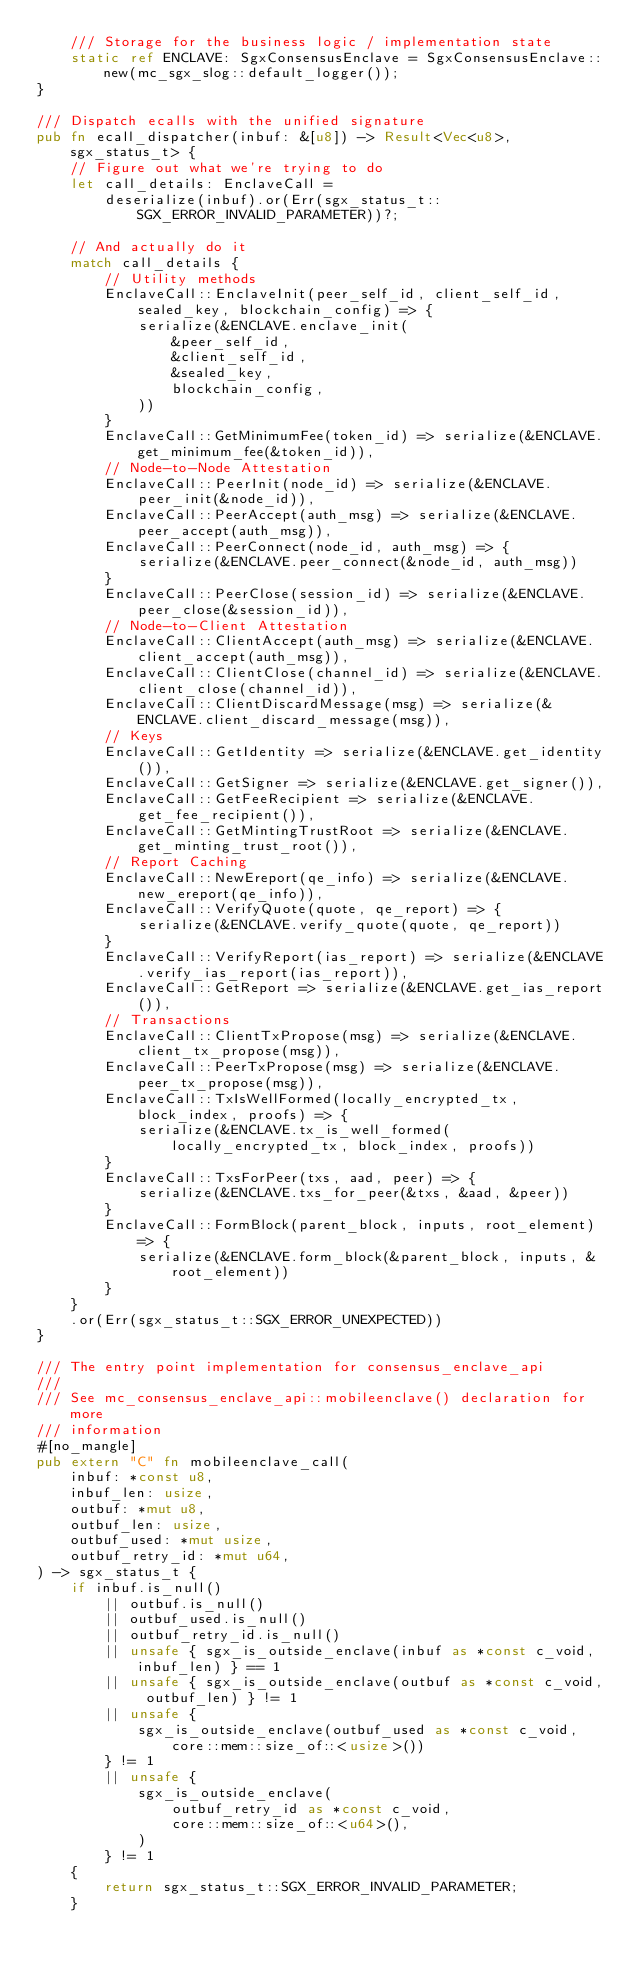Convert code to text. <code><loc_0><loc_0><loc_500><loc_500><_Rust_>    /// Storage for the business logic / implementation state
    static ref ENCLAVE: SgxConsensusEnclave = SgxConsensusEnclave::new(mc_sgx_slog::default_logger());
}

/// Dispatch ecalls with the unified signature
pub fn ecall_dispatcher(inbuf: &[u8]) -> Result<Vec<u8>, sgx_status_t> {
    // Figure out what we're trying to do
    let call_details: EnclaveCall =
        deserialize(inbuf).or(Err(sgx_status_t::SGX_ERROR_INVALID_PARAMETER))?;

    // And actually do it
    match call_details {
        // Utility methods
        EnclaveCall::EnclaveInit(peer_self_id, client_self_id, sealed_key, blockchain_config) => {
            serialize(&ENCLAVE.enclave_init(
                &peer_self_id,
                &client_self_id,
                &sealed_key,
                blockchain_config,
            ))
        }
        EnclaveCall::GetMinimumFee(token_id) => serialize(&ENCLAVE.get_minimum_fee(&token_id)),
        // Node-to-Node Attestation
        EnclaveCall::PeerInit(node_id) => serialize(&ENCLAVE.peer_init(&node_id)),
        EnclaveCall::PeerAccept(auth_msg) => serialize(&ENCLAVE.peer_accept(auth_msg)),
        EnclaveCall::PeerConnect(node_id, auth_msg) => {
            serialize(&ENCLAVE.peer_connect(&node_id, auth_msg))
        }
        EnclaveCall::PeerClose(session_id) => serialize(&ENCLAVE.peer_close(&session_id)),
        // Node-to-Client Attestation
        EnclaveCall::ClientAccept(auth_msg) => serialize(&ENCLAVE.client_accept(auth_msg)),
        EnclaveCall::ClientClose(channel_id) => serialize(&ENCLAVE.client_close(channel_id)),
        EnclaveCall::ClientDiscardMessage(msg) => serialize(&ENCLAVE.client_discard_message(msg)),
        // Keys
        EnclaveCall::GetIdentity => serialize(&ENCLAVE.get_identity()),
        EnclaveCall::GetSigner => serialize(&ENCLAVE.get_signer()),
        EnclaveCall::GetFeeRecipient => serialize(&ENCLAVE.get_fee_recipient()),
        EnclaveCall::GetMintingTrustRoot => serialize(&ENCLAVE.get_minting_trust_root()),
        // Report Caching
        EnclaveCall::NewEreport(qe_info) => serialize(&ENCLAVE.new_ereport(qe_info)),
        EnclaveCall::VerifyQuote(quote, qe_report) => {
            serialize(&ENCLAVE.verify_quote(quote, qe_report))
        }
        EnclaveCall::VerifyReport(ias_report) => serialize(&ENCLAVE.verify_ias_report(ias_report)),
        EnclaveCall::GetReport => serialize(&ENCLAVE.get_ias_report()),
        // Transactions
        EnclaveCall::ClientTxPropose(msg) => serialize(&ENCLAVE.client_tx_propose(msg)),
        EnclaveCall::PeerTxPropose(msg) => serialize(&ENCLAVE.peer_tx_propose(msg)),
        EnclaveCall::TxIsWellFormed(locally_encrypted_tx, block_index, proofs) => {
            serialize(&ENCLAVE.tx_is_well_formed(locally_encrypted_tx, block_index, proofs))
        }
        EnclaveCall::TxsForPeer(txs, aad, peer) => {
            serialize(&ENCLAVE.txs_for_peer(&txs, &aad, &peer))
        }
        EnclaveCall::FormBlock(parent_block, inputs, root_element) => {
            serialize(&ENCLAVE.form_block(&parent_block, inputs, &root_element))
        }
    }
    .or(Err(sgx_status_t::SGX_ERROR_UNEXPECTED))
}

/// The entry point implementation for consensus_enclave_api
///
/// See mc_consensus_enclave_api::mobileenclave() declaration for more
/// information
#[no_mangle]
pub extern "C" fn mobileenclave_call(
    inbuf: *const u8,
    inbuf_len: usize,
    outbuf: *mut u8,
    outbuf_len: usize,
    outbuf_used: *mut usize,
    outbuf_retry_id: *mut u64,
) -> sgx_status_t {
    if inbuf.is_null()
        || outbuf.is_null()
        || outbuf_used.is_null()
        || outbuf_retry_id.is_null()
        || unsafe { sgx_is_outside_enclave(inbuf as *const c_void, inbuf_len) } == 1
        || unsafe { sgx_is_outside_enclave(outbuf as *const c_void, outbuf_len) } != 1
        || unsafe {
            sgx_is_outside_enclave(outbuf_used as *const c_void, core::mem::size_of::<usize>())
        } != 1
        || unsafe {
            sgx_is_outside_enclave(
                outbuf_retry_id as *const c_void,
                core::mem::size_of::<u64>(),
            )
        } != 1
    {
        return sgx_status_t::SGX_ERROR_INVALID_PARAMETER;
    }
</code> 